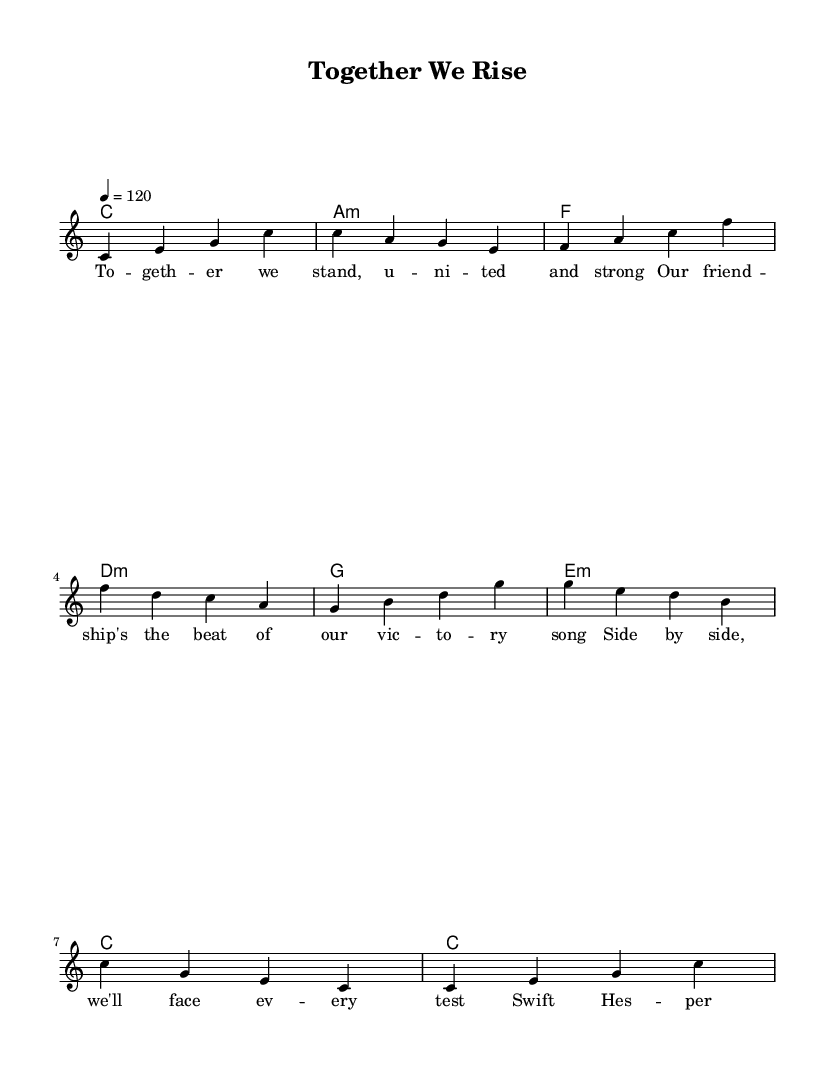What is the key signature of this music? The key signature indicated at the beginning of the music is C major, which has no sharps or flats.
Answer: C major What is the time signature of this music? The time signature shown at the start of the music is 4/4, which means there are four beats in each measure.
Answer: 4/4 What is the tempo marking for this piece? The tempo marking indicates a quarter note equals 120 beats per minute, which defines how fast the piece should be played.
Answer: 120 How many measures are in the melody? By counting the separated groups of notes that are grouped visually, there are 8 measures in the melody section.
Answer: 8 Which chord is played in the first measure? The first measure shows a C major chord, often represented at the beginning of the score as it sets the key for the piece.
Answer: C What is the primary theme expressed in the lyrics? The lyrics emphasize teamwork and friendship, highlighting unity and support among friends, particularly referencing "Swift Hesperange."
Answer: Teamwork What type of song structure is used here? The music displays a verse structure, as indicated by the lyrical layout and repetition that typically occurs in upbeat pop songs.
Answer: Verse 